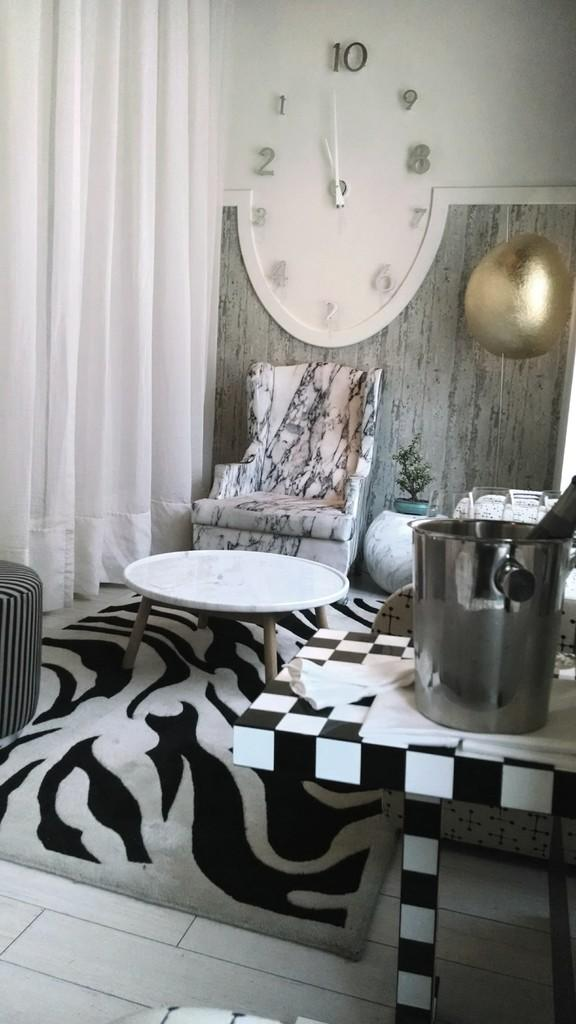What type of furniture is present in the image? There is a chair and a table in the image. What type of textile is visible in the image? There is cloth in the image. What type of floor covering is present in the image? There is a carpet in the image. What type of plant is present in the image? There is a house plant in the image. What type of architectural feature is present in the image? There is a wall in the image. What type of container is present in the image? There is a steel container in the image. Where is the field located in the image? There is no field present in the image. What type of needle is used to sew the cloth in the image? There is no needle present in the image, and the cloth is not being sewn. What type of shelf is present in the image? There is no shelf present in the image. 